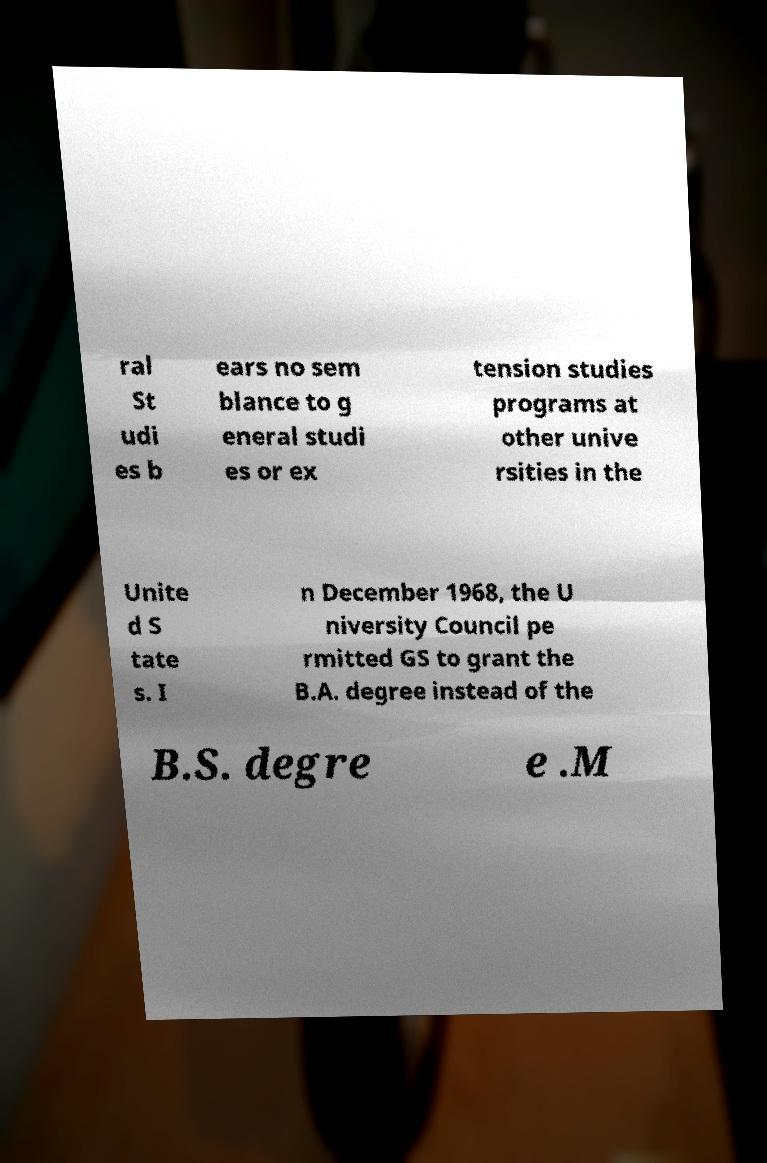Could you assist in decoding the text presented in this image and type it out clearly? ral St udi es b ears no sem blance to g eneral studi es or ex tension studies programs at other unive rsities in the Unite d S tate s. I n December 1968, the U niversity Council pe rmitted GS to grant the B.A. degree instead of the B.S. degre e .M 